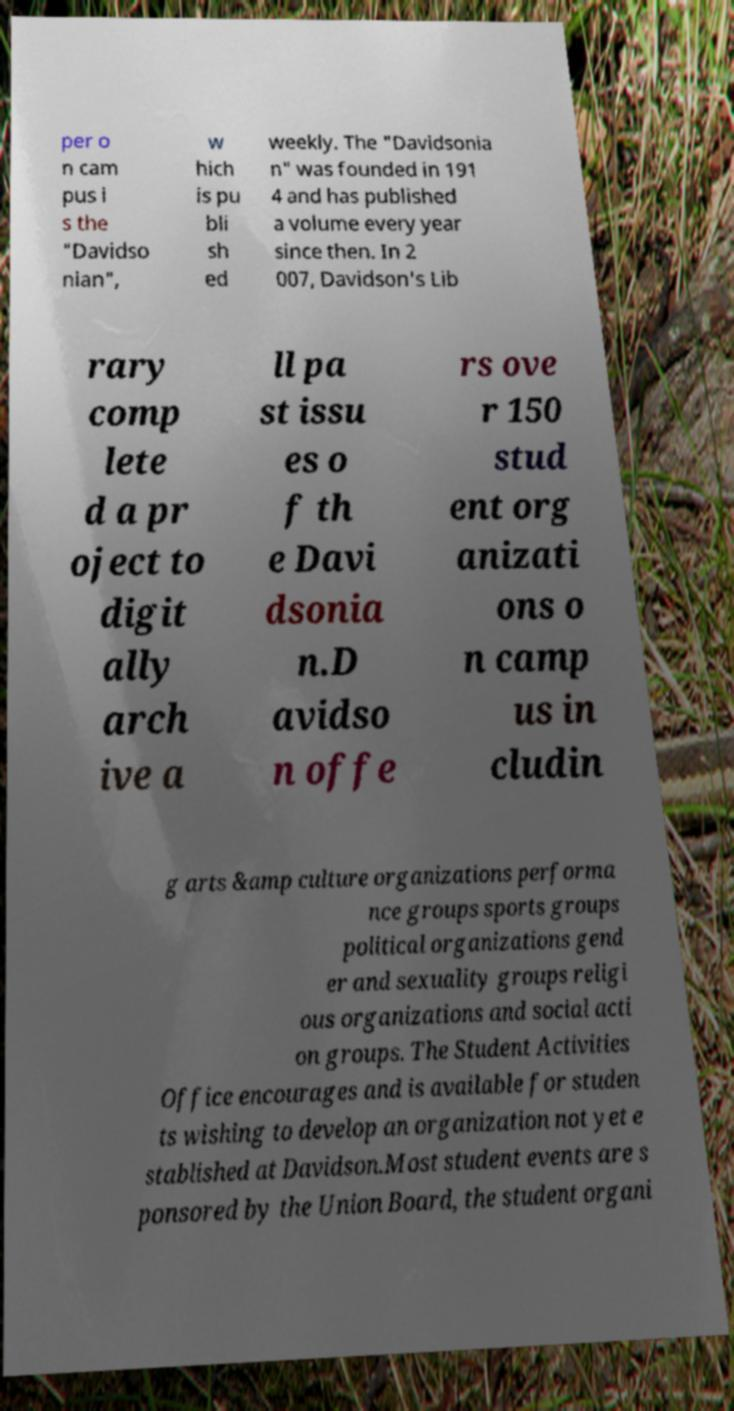For documentation purposes, I need the text within this image transcribed. Could you provide that? per o n cam pus i s the "Davidso nian", w hich is pu bli sh ed weekly. The "Davidsonia n" was founded in 191 4 and has published a volume every year since then. In 2 007, Davidson's Lib rary comp lete d a pr oject to digit ally arch ive a ll pa st issu es o f th e Davi dsonia n.D avidso n offe rs ove r 150 stud ent org anizati ons o n camp us in cludin g arts &amp culture organizations performa nce groups sports groups political organizations gend er and sexuality groups religi ous organizations and social acti on groups. The Student Activities Office encourages and is available for studen ts wishing to develop an organization not yet e stablished at Davidson.Most student events are s ponsored by the Union Board, the student organi 